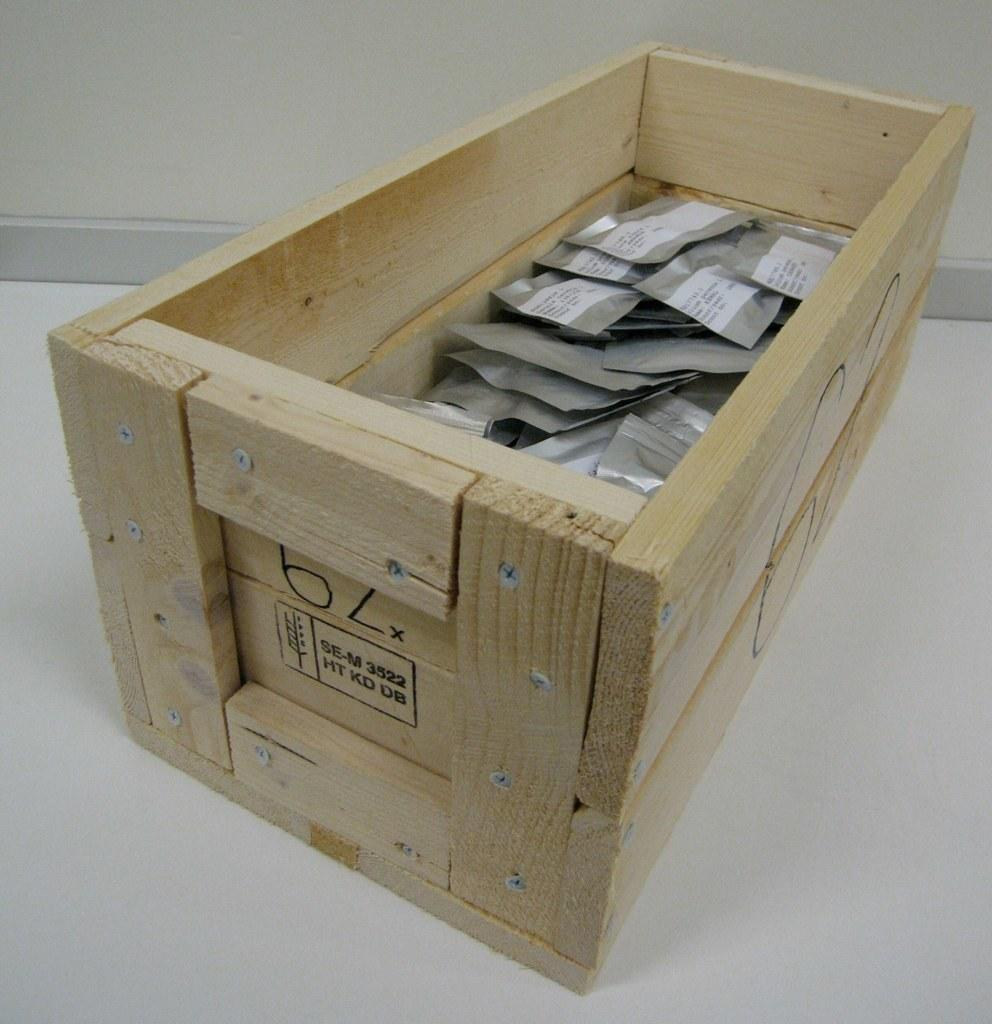What is the main object in the image? There is a wooden box in the image. What is inside the wooden box? The wooden box contains objects. Where is the wooden box located? The wooden box is on the ground. What can be seen in the background of the image? There is a wall in the background of the image. What time of day is it in the image, based on the need for artificial light? The image does not provide information about the time of day or the need for artificial light, so it cannot be determined from the image. 